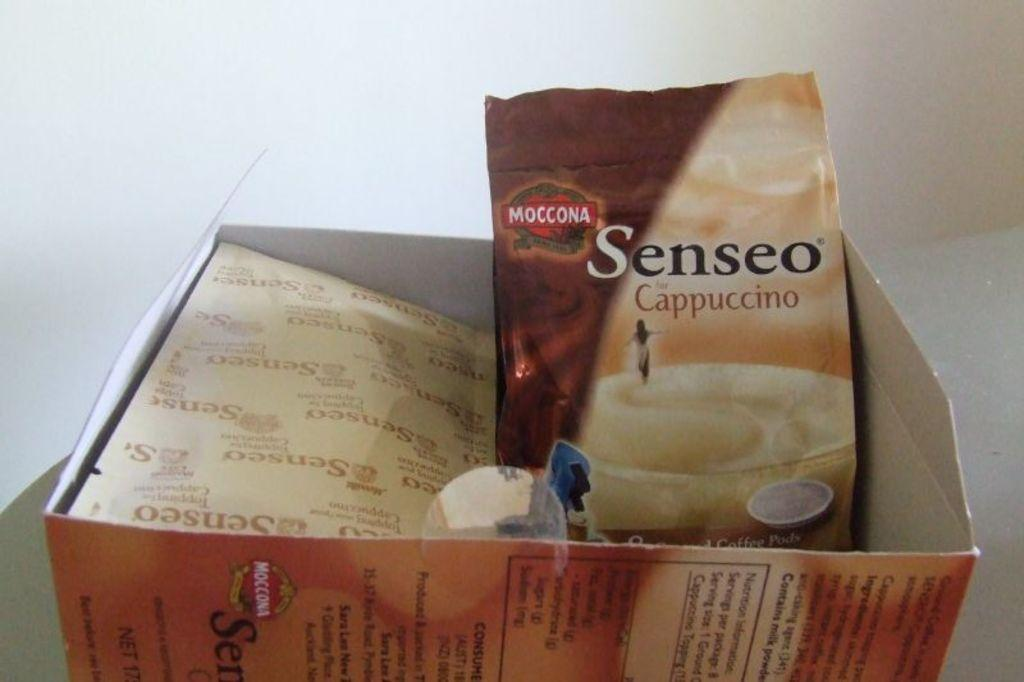<image>
Give a short and clear explanation of the subsequent image. a bag of moccona senseo cappuccino inside of a box 